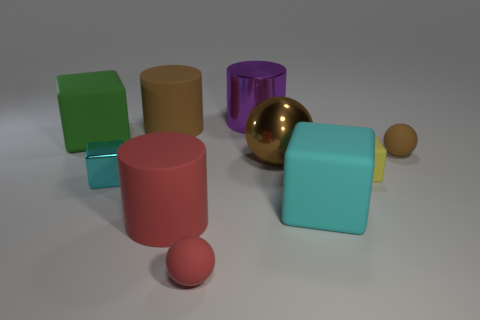Subtract all brown balls. How many balls are left? 1 Subtract 3 cylinders. How many cylinders are left? 0 Subtract all green blocks. How many blocks are left? 3 Subtract all blocks. How many objects are left? 6 Add 2 green matte blocks. How many green matte blocks are left? 3 Add 8 tiny balls. How many tiny balls exist? 10 Subtract 0 red cubes. How many objects are left? 10 Subtract all blue cylinders. Subtract all blue blocks. How many cylinders are left? 3 Subtract all green spheres. How many yellow blocks are left? 1 Subtract all brown matte spheres. Subtract all purple cylinders. How many objects are left? 8 